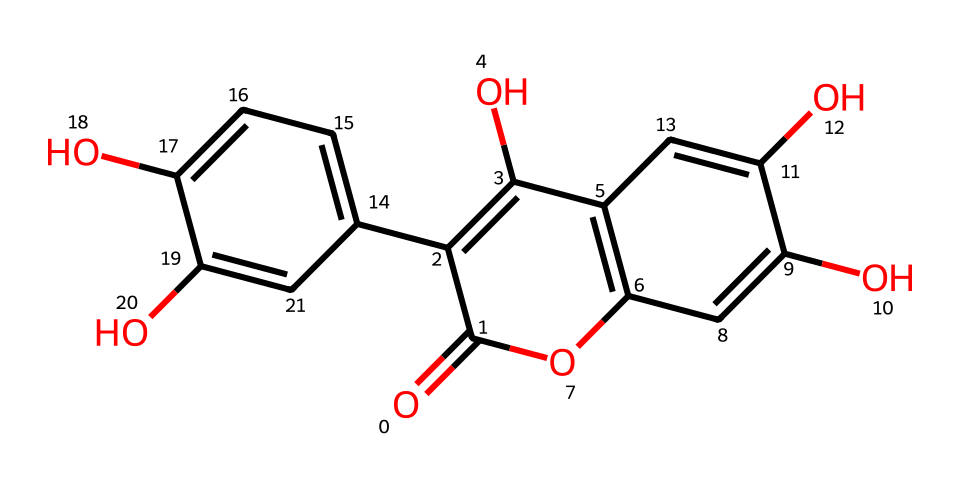What is the molecular formula of quercetin? To derive the molecular formula from the SMILES representation, we identify the atoms present in the structure: including carbon, hydrogen, and oxygen. Counting each type, quercetin comprises 15 carbon atoms, 10 hydrogen atoms, and 7 oxygen atoms, leading to the formula C15H10O7.
Answer: C15H10O7 How many rings are present in the quercetin structure? By closely examining the structural representation from the SMILES, we see that there are three distinct cyclic structures indicating the presence of three rings.
Answer: 3 What type of compound is quercetin classified as? Quercetin contains hydroxyl groups and displays its properties as an antioxidant, which fits the classification as a flavonoid.
Answer: flavonoid What functional groups are present in quercetin? Analyzing the structure reveals multiple hydroxyl (-OH) groups attached to the carbon skeleton, which are characteristic functional groups in quercetin, contributing to its antioxidant properties.
Answer: hydroxyl groups Which atoms are the most abundant in quercetin? In quercetin, the most abundant atoms are carbon, which occurs 15 times in the molecular structure, making it the most prevalent element compared to others like hydrogen and oxygen.
Answer: carbon 